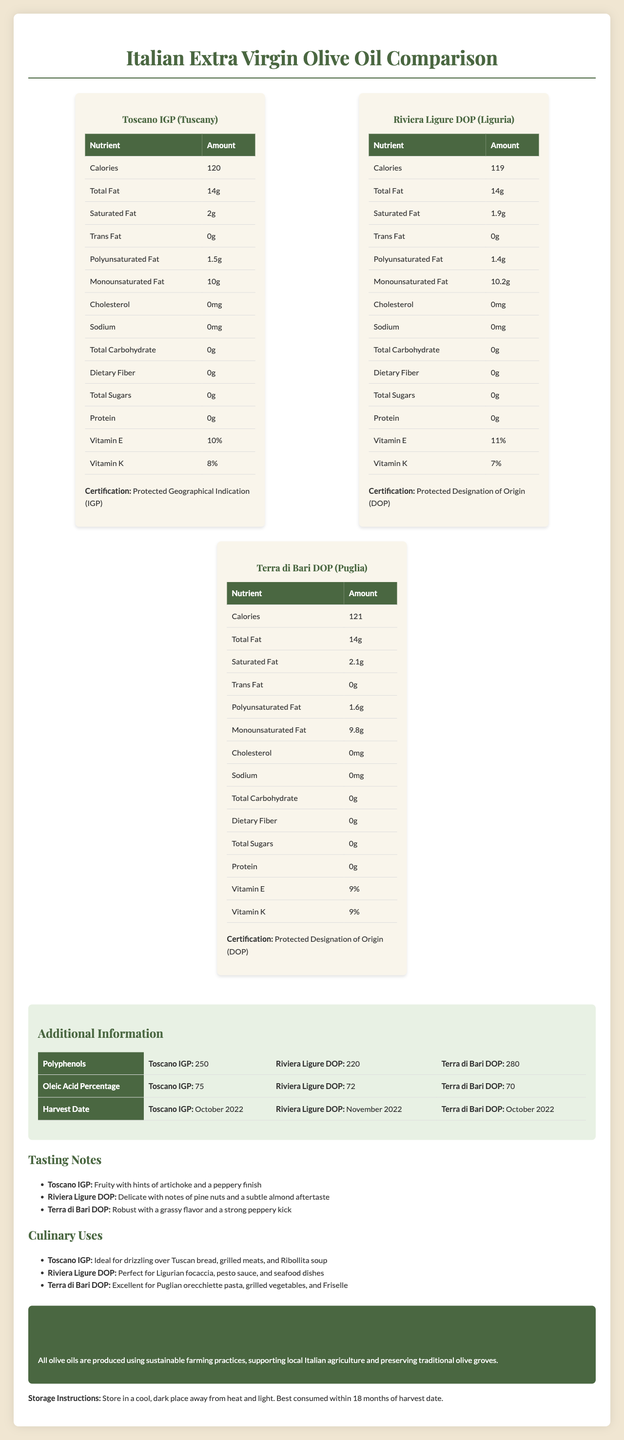what is the caloric content of "Toscano IGP" per serving? The caloric content of "Toscano IGP" per serving is 120 calories, as specified in the nutrition facts section for this variety.
Answer: 120 calories how much monounsaturated fat is in "Riviera Ligure DOP"? "Riviera Ligure DOP" contains 10.2 grams of monounsaturated fat per serving, according to the nutrition facts table.
Answer: 10.2 grams which variety has the highest polyphenol content? "Terra di Bari DOP" has the highest polyphenol content with 280 mg, as listed in the additional information table.
Answer: Terra di Bari DOP what are the tasting notes for "Terra di Bari DOP"? The tasting notes for "Terra di Bari DOP" describe it as robust with a grassy flavor and a strong peppery kick.
Answer: Robust with a grassy flavor and a strong peppery kick how long should the olive oils be stored? The olive oils should be consumed within 18 months of their respective harvest dates, as mentioned in the storage instructions.
Answer: Within 18 months of the harvest date which vitamin is present in the highest percentage in "Riviera Ligure DOP"? A. Vitamin E B. Vitamin K C. Vitamin C D. Vitamin A The nutrition facts state that "Riviera Ligure DOP" contains 11% of Vitamin E and 7% of Vitamin K, with Vitamin E being the highest percentage.
Answer: A. Vitamin E which region produces "Toscano IGP"? 1. Puglia 2. Tuscany 3. Liguria 4. Sicily "Toscano IGP" is produced in the Tuscany region, as stated in the document.
Answer: 2. Tuscany does "Toscano IGP" contain any cholesterol? According to the nutrition facts, "Toscano IGP" contains 0 mg of cholesterol.
Answer: No summarize the document in one sentence. The document provides a comparative analysis of "Toscano IGP," "Riviera Ligure DOP," and "Terra di Bari DOP," detailing their nutritional facts, tasting notes, culinary uses, and additional aspects such as polyphenol content, oleic acid percentage, and sustainability practices.
Answer: The document compares the nutritional content, tasting notes, culinary uses, and additional information of three varieties of Italian Extra Virgin Olive Oils from different regions, highlighting their unique characteristics and nutritional benefits. what is the polyunsaturated fat content of the variety with the highest oleic acid percentage? "Toscano IGP" has the highest oleic acid percentage at 75%, and its polyunsaturated fat content is 1.5 grams, as shown in the document.
Answer: 1.5 grams how many varieties are lower in calories compared to "Terra di Bari DOP"? "Toscano IGP" (120 calories) and "Riviera Ligure DOP" (119 calories) both have fewer calories than "Terra di Bari DOP" (121 calories).
Answer: Two who is the producer of the olive oils? The document does not provide information about the specific producers of the olive oils, only the regions and designations.
Answer: Cannot be determined 